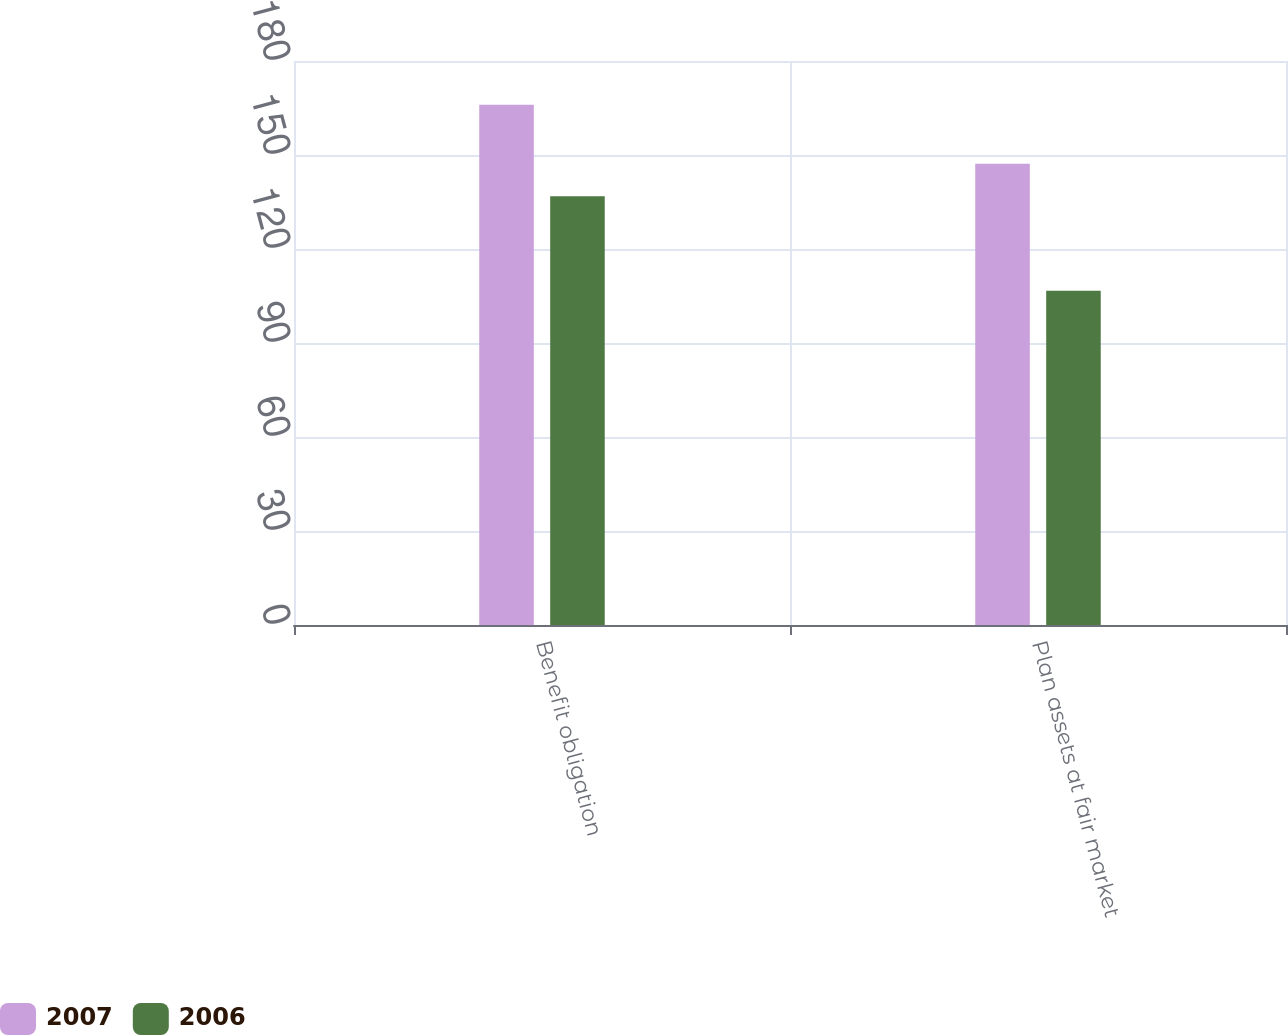Convert chart to OTSL. <chart><loc_0><loc_0><loc_500><loc_500><stacked_bar_chart><ecel><fcel>Benefit obligation<fcel>Plan assets at fair market<nl><fcel>2007<fcel>166<fcel>147.2<nl><fcel>2006<fcel>136.8<fcel>106.7<nl></chart> 